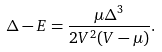Convert formula to latex. <formula><loc_0><loc_0><loc_500><loc_500>\Delta - E = \frac { \mu \Delta ^ { 3 } } { 2 V ^ { 2 } ( V - \mu ) } .</formula> 